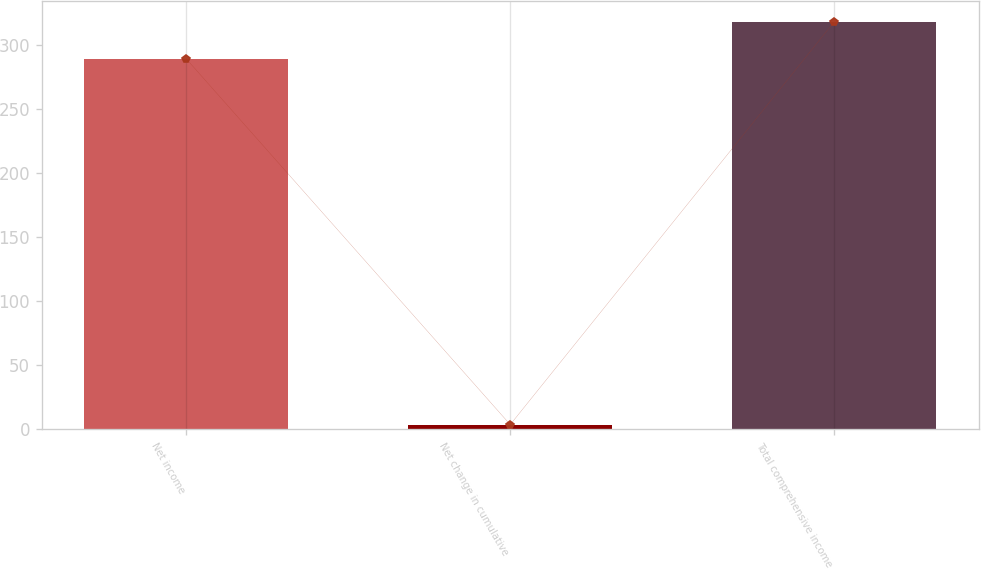<chart> <loc_0><loc_0><loc_500><loc_500><bar_chart><fcel>Net income<fcel>Net change in cumulative<fcel>Total comprehensive income<nl><fcel>289.7<fcel>3.8<fcel>318.67<nl></chart> 